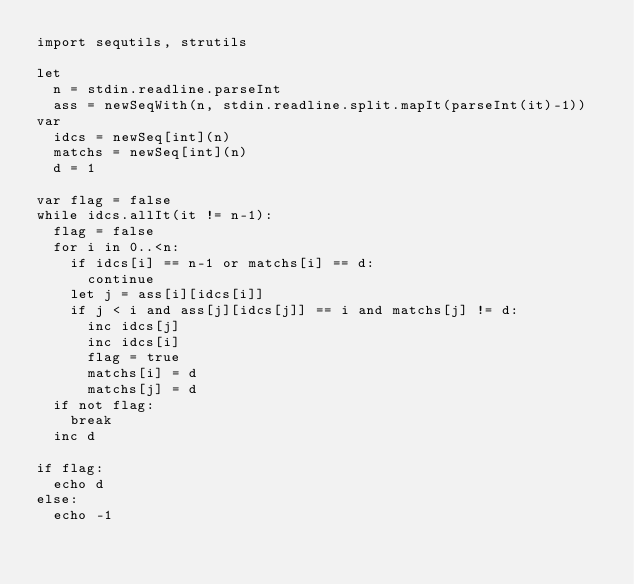Convert code to text. <code><loc_0><loc_0><loc_500><loc_500><_Nim_>import sequtils, strutils

let
  n = stdin.readline.parseInt
  ass = newSeqWith(n, stdin.readline.split.mapIt(parseInt(it)-1))
var
  idcs = newSeq[int](n)
  matchs = newSeq[int](n)
  d = 1

var flag = false
while idcs.allIt(it != n-1):
  flag = false
  for i in 0..<n:
    if idcs[i] == n-1 or matchs[i] == d:
      continue
    let j = ass[i][idcs[i]]
    if j < i and ass[j][idcs[j]] == i and matchs[j] != d:
      inc idcs[j]
      inc idcs[i]
      flag = true
      matchs[i] = d
      matchs[j] = d
  if not flag:
    break
  inc d

if flag:
  echo d
else:
  echo -1
</code> 